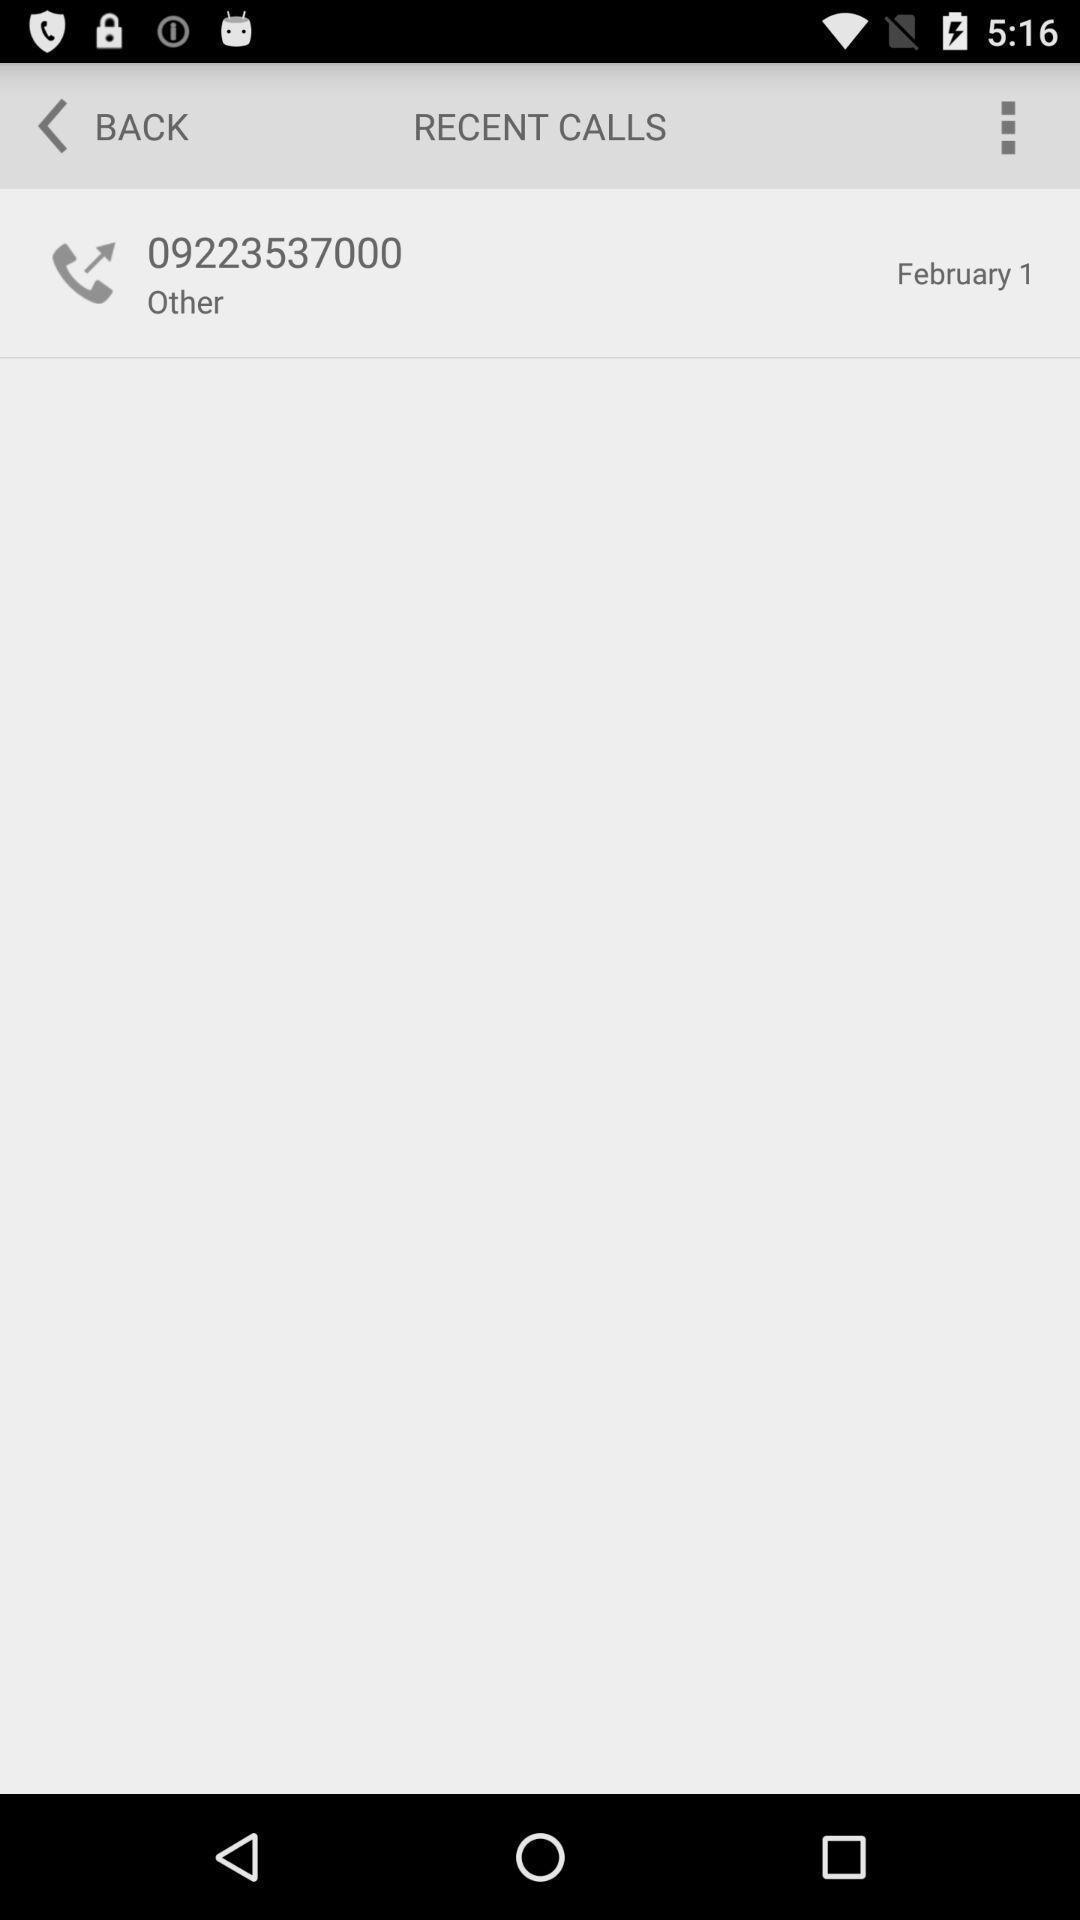Tell me about the visual elements in this screen capture. Screen displaying the contact number in recent calls page. 